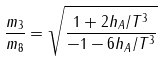Convert formula to latex. <formula><loc_0><loc_0><loc_500><loc_500>\frac { m _ { 3 } } { m _ { 8 } } = \sqrt { \frac { 1 + 2 h _ { A } / T ^ { 3 } } { - 1 - 6 h _ { A } / T ^ { 3 } } }</formula> 